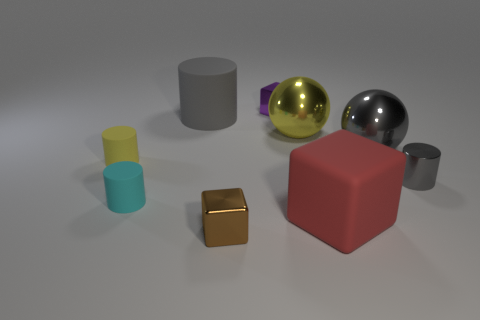What number of large matte cylinders are the same color as the tiny metallic cylinder?
Provide a succinct answer. 1. What is the color of the block that is made of the same material as the tiny purple object?
Your answer should be compact. Brown. Do the small brown metallic thing that is to the left of the tiny purple object and the purple object have the same shape?
Your answer should be compact. Yes. How many objects are rubber objects that are left of the cyan rubber cylinder or tiny metal things behind the cyan rubber cylinder?
Give a very brief answer. 3. What color is the big object that is the same shape as the small yellow object?
Give a very brief answer. Gray. There is a big yellow object; is it the same shape as the large gray thing that is in front of the large yellow thing?
Your response must be concise. Yes. What is the material of the brown object?
Make the answer very short. Metal. There is a gray rubber thing that is the same shape as the cyan thing; what size is it?
Offer a terse response. Large. How many other objects are the same material as the small yellow cylinder?
Provide a succinct answer. 3. Do the large yellow object and the large thing in front of the small cyan thing have the same material?
Make the answer very short. No. 